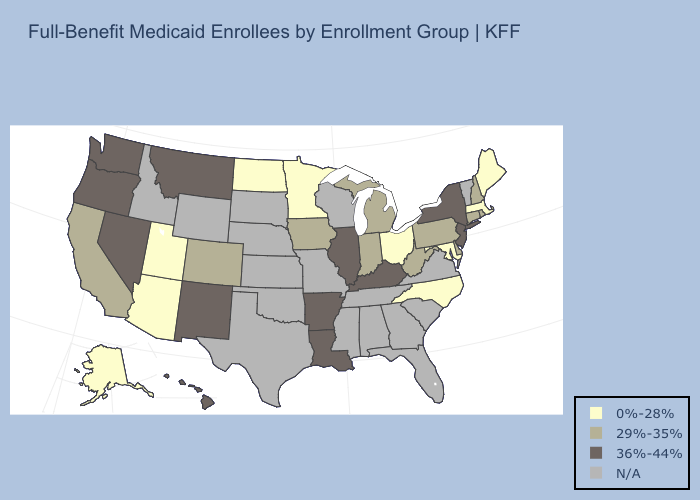Among the states that border California , which have the lowest value?
Short answer required. Arizona. Does the first symbol in the legend represent the smallest category?
Give a very brief answer. Yes. Does the first symbol in the legend represent the smallest category?
Be succinct. Yes. Name the states that have a value in the range N/A?
Write a very short answer. Alabama, Florida, Georgia, Idaho, Kansas, Mississippi, Missouri, Nebraska, Oklahoma, South Carolina, South Dakota, Tennessee, Texas, Vermont, Virginia, Wisconsin, Wyoming. Does New Mexico have the lowest value in the USA?
Be succinct. No. What is the highest value in the USA?
Answer briefly. 36%-44%. Which states have the lowest value in the USA?
Answer briefly. Alaska, Arizona, Maine, Maryland, Massachusetts, Minnesota, North Carolina, North Dakota, Ohio, Utah. Does Delaware have the highest value in the USA?
Short answer required. No. Does Michigan have the highest value in the USA?
Be succinct. No. What is the value of Hawaii?
Give a very brief answer. 36%-44%. Name the states that have a value in the range N/A?
Keep it brief. Alabama, Florida, Georgia, Idaho, Kansas, Mississippi, Missouri, Nebraska, Oklahoma, South Carolina, South Dakota, Tennessee, Texas, Vermont, Virginia, Wisconsin, Wyoming. Which states have the highest value in the USA?
Answer briefly. Arkansas, Hawaii, Illinois, Kentucky, Louisiana, Montana, Nevada, New Jersey, New Mexico, New York, Oregon, Washington. What is the value of Kentucky?
Concise answer only. 36%-44%. Which states have the lowest value in the West?
Give a very brief answer. Alaska, Arizona, Utah. 